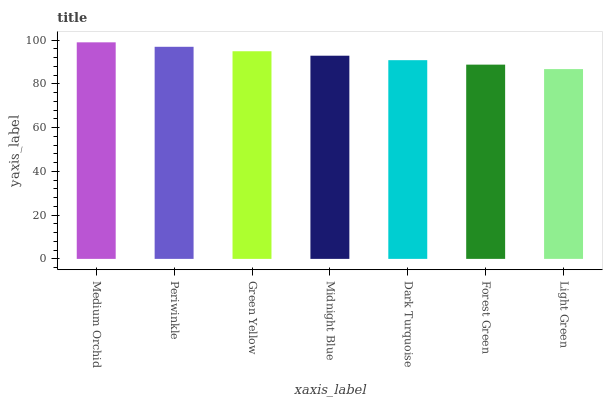Is Light Green the minimum?
Answer yes or no. Yes. Is Medium Orchid the maximum?
Answer yes or no. Yes. Is Periwinkle the minimum?
Answer yes or no. No. Is Periwinkle the maximum?
Answer yes or no. No. Is Medium Orchid greater than Periwinkle?
Answer yes or no. Yes. Is Periwinkle less than Medium Orchid?
Answer yes or no. Yes. Is Periwinkle greater than Medium Orchid?
Answer yes or no. No. Is Medium Orchid less than Periwinkle?
Answer yes or no. No. Is Midnight Blue the high median?
Answer yes or no. Yes. Is Midnight Blue the low median?
Answer yes or no. Yes. Is Green Yellow the high median?
Answer yes or no. No. Is Forest Green the low median?
Answer yes or no. No. 